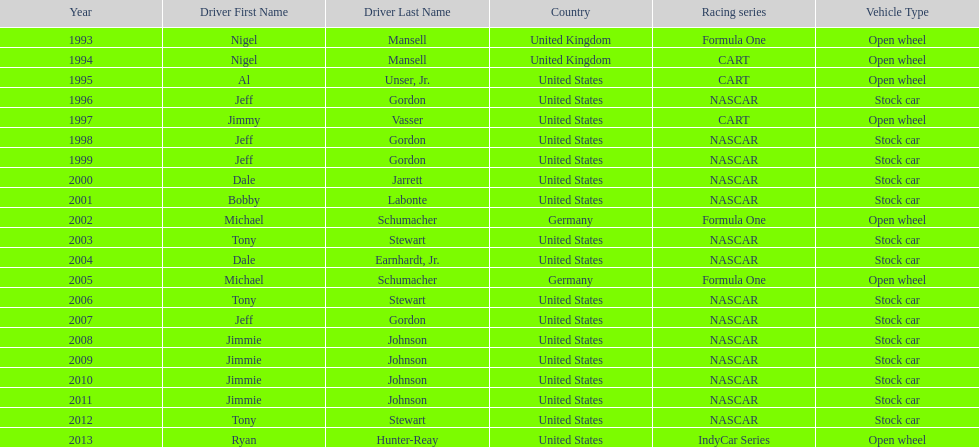Besides nascar, what other racing series have espy-winning drivers come from? Formula One, CART, IndyCar Series. 